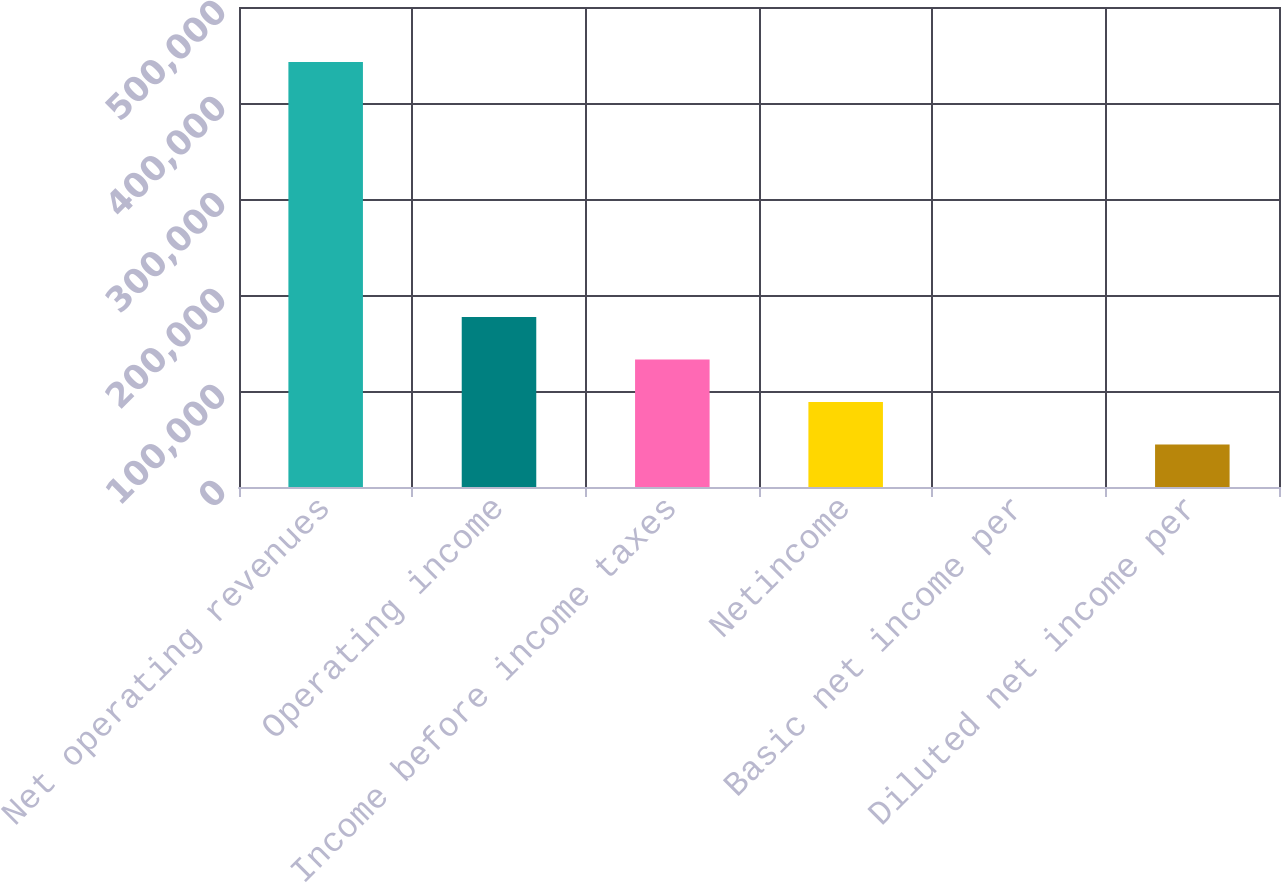Convert chart to OTSL. <chart><loc_0><loc_0><loc_500><loc_500><bar_chart><fcel>Net operating revenues<fcel>Operating income<fcel>Income before income taxes<fcel>Netincome<fcel>Basic net income per<fcel>Diluted net income per<nl><fcel>442677<fcel>177071<fcel>132803<fcel>88535.5<fcel>0.1<fcel>44267.8<nl></chart> 